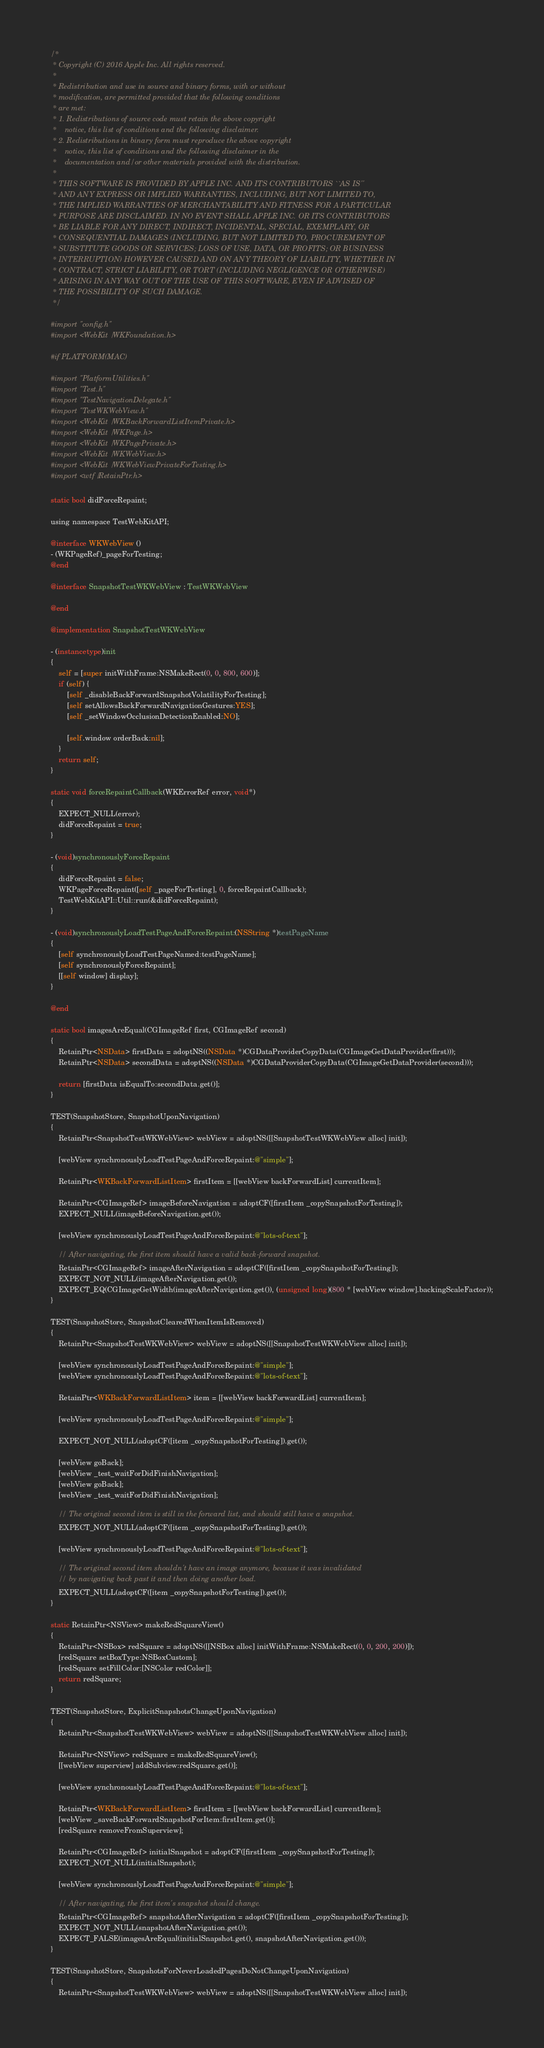<code> <loc_0><loc_0><loc_500><loc_500><_ObjectiveC_>/*
 * Copyright (C) 2016 Apple Inc. All rights reserved.
 *
 * Redistribution and use in source and binary forms, with or without
 * modification, are permitted provided that the following conditions
 * are met:
 * 1. Redistributions of source code must retain the above copyright
 *    notice, this list of conditions and the following disclaimer.
 * 2. Redistributions in binary form must reproduce the above copyright
 *    notice, this list of conditions and the following disclaimer in the
 *    documentation and/or other materials provided with the distribution.
 *
 * THIS SOFTWARE IS PROVIDED BY APPLE INC. AND ITS CONTRIBUTORS ``AS IS''
 * AND ANY EXPRESS OR IMPLIED WARRANTIES, INCLUDING, BUT NOT LIMITED TO,
 * THE IMPLIED WARRANTIES OF MERCHANTABILITY AND FITNESS FOR A PARTICULAR
 * PURPOSE ARE DISCLAIMED. IN NO EVENT SHALL APPLE INC. OR ITS CONTRIBUTORS
 * BE LIABLE FOR ANY DIRECT, INDIRECT, INCIDENTAL, SPECIAL, EXEMPLARY, OR
 * CONSEQUENTIAL DAMAGES (INCLUDING, BUT NOT LIMITED TO, PROCUREMENT OF
 * SUBSTITUTE GOODS OR SERVICES; LOSS OF USE, DATA, OR PROFITS; OR BUSINESS
 * INTERRUPTION) HOWEVER CAUSED AND ON ANY THEORY OF LIABILITY, WHETHER IN
 * CONTRACT, STRICT LIABILITY, OR TORT (INCLUDING NEGLIGENCE OR OTHERWISE)
 * ARISING IN ANY WAY OUT OF THE USE OF THIS SOFTWARE, EVEN IF ADVISED OF
 * THE POSSIBILITY OF SUCH DAMAGE.
 */

#import "config.h"
#import <WebKit/WKFoundation.h>

#if PLATFORM(MAC)

#import "PlatformUtilities.h"
#import "Test.h"
#import "TestNavigationDelegate.h"
#import "TestWKWebView.h"
#import <WebKit/WKBackForwardListItemPrivate.h>
#import <WebKit/WKPage.h>
#import <WebKit/WKPagePrivate.h>
#import <WebKit/WKWebView.h>
#import <WebKit/WKWebViewPrivateForTesting.h>
#import <wtf/RetainPtr.h>

static bool didForceRepaint;

using namespace TestWebKitAPI;

@interface WKWebView ()
- (WKPageRef)_pageForTesting;
@end

@interface SnapshotTestWKWebView : TestWKWebView

@end

@implementation SnapshotTestWKWebView

- (instancetype)init
{
    self = [super initWithFrame:NSMakeRect(0, 0, 800, 600)];
    if (self) {
        [self _disableBackForwardSnapshotVolatilityForTesting];
        [self setAllowsBackForwardNavigationGestures:YES];
        [self _setWindowOcclusionDetectionEnabled:NO];

        [self.window orderBack:nil];
    }
    return self;
}

static void forceRepaintCallback(WKErrorRef error, void*)
{
    EXPECT_NULL(error);
    didForceRepaint = true;
}

- (void)synchronouslyForceRepaint
{
    didForceRepaint = false;
    WKPageForceRepaint([self _pageForTesting], 0, forceRepaintCallback);
    TestWebKitAPI::Util::run(&didForceRepaint);
}

- (void)synchronouslyLoadTestPageAndForceRepaint:(NSString *)testPageName
{
    [self synchronouslyLoadTestPageNamed:testPageName];
    [self synchronouslyForceRepaint];
    [[self window] display];
}

@end

static bool imagesAreEqual(CGImageRef first, CGImageRef second)
{
    RetainPtr<NSData> firstData = adoptNS((NSData *)CGDataProviderCopyData(CGImageGetDataProvider(first)));
    RetainPtr<NSData> secondData = adoptNS((NSData *)CGDataProviderCopyData(CGImageGetDataProvider(second)));

    return [firstData isEqualTo:secondData.get()];
}

TEST(SnapshotStore, SnapshotUponNavigation)
{
    RetainPtr<SnapshotTestWKWebView> webView = adoptNS([[SnapshotTestWKWebView alloc] init]);

    [webView synchronouslyLoadTestPageAndForceRepaint:@"simple"];

    RetainPtr<WKBackForwardListItem> firstItem = [[webView backForwardList] currentItem];

    RetainPtr<CGImageRef> imageBeforeNavigation = adoptCF([firstItem _copySnapshotForTesting]);
    EXPECT_NULL(imageBeforeNavigation.get());

    [webView synchronouslyLoadTestPageAndForceRepaint:@"lots-of-text"];

    // After navigating, the first item should have a valid back-forward snapshot.
    RetainPtr<CGImageRef> imageAfterNavigation = adoptCF([firstItem _copySnapshotForTesting]);
    EXPECT_NOT_NULL(imageAfterNavigation.get());
    EXPECT_EQ(CGImageGetWidth(imageAfterNavigation.get()), (unsigned long)(800 * [webView window].backingScaleFactor));
}

TEST(SnapshotStore, SnapshotClearedWhenItemIsRemoved)
{
    RetainPtr<SnapshotTestWKWebView> webView = adoptNS([[SnapshotTestWKWebView alloc] init]);

    [webView synchronouslyLoadTestPageAndForceRepaint:@"simple"];
    [webView synchronouslyLoadTestPageAndForceRepaint:@"lots-of-text"];

    RetainPtr<WKBackForwardListItem> item = [[webView backForwardList] currentItem];

    [webView synchronouslyLoadTestPageAndForceRepaint:@"simple"];

    EXPECT_NOT_NULL(adoptCF([item _copySnapshotForTesting]).get());

    [webView goBack];
    [webView _test_waitForDidFinishNavigation];
    [webView goBack];
    [webView _test_waitForDidFinishNavigation];

    // The original second item is still in the forward list, and should still have a snapshot.
    EXPECT_NOT_NULL(adoptCF([item _copySnapshotForTesting]).get());

    [webView synchronouslyLoadTestPageAndForceRepaint:@"lots-of-text"];

    // The original second item shouldn't have an image anymore, because it was invalidated
    // by navigating back past it and then doing another load.
    EXPECT_NULL(adoptCF([item _copySnapshotForTesting]).get());
}

static RetainPtr<NSView> makeRedSquareView()
{
    RetainPtr<NSBox> redSquare = adoptNS([[NSBox alloc] initWithFrame:NSMakeRect(0, 0, 200, 200)]);
    [redSquare setBoxType:NSBoxCustom];
    [redSquare setFillColor:[NSColor redColor]];
    return redSquare;
}

TEST(SnapshotStore, ExplicitSnapshotsChangeUponNavigation)
{
    RetainPtr<SnapshotTestWKWebView> webView = adoptNS([[SnapshotTestWKWebView alloc] init]);

    RetainPtr<NSView> redSquare = makeRedSquareView();
    [[webView superview] addSubview:redSquare.get()];

    [webView synchronouslyLoadTestPageAndForceRepaint:@"lots-of-text"];

    RetainPtr<WKBackForwardListItem> firstItem = [[webView backForwardList] currentItem];
    [webView _saveBackForwardSnapshotForItem:firstItem.get()];
    [redSquare removeFromSuperview];

    RetainPtr<CGImageRef> initialSnapshot = adoptCF([firstItem _copySnapshotForTesting]);
    EXPECT_NOT_NULL(initialSnapshot);

    [webView synchronouslyLoadTestPageAndForceRepaint:@"simple"];

    // After navigating, the first item's snapshot should change.
    RetainPtr<CGImageRef> snapshotAfterNavigation = adoptCF([firstItem _copySnapshotForTesting]);
    EXPECT_NOT_NULL(snapshotAfterNavigation.get());
    EXPECT_FALSE(imagesAreEqual(initialSnapshot.get(), snapshotAfterNavigation.get()));
}

TEST(SnapshotStore, SnapshotsForNeverLoadedPagesDoNotChangeUponNavigation)
{
    RetainPtr<SnapshotTestWKWebView> webView = adoptNS([[SnapshotTestWKWebView alloc] init]);
</code> 